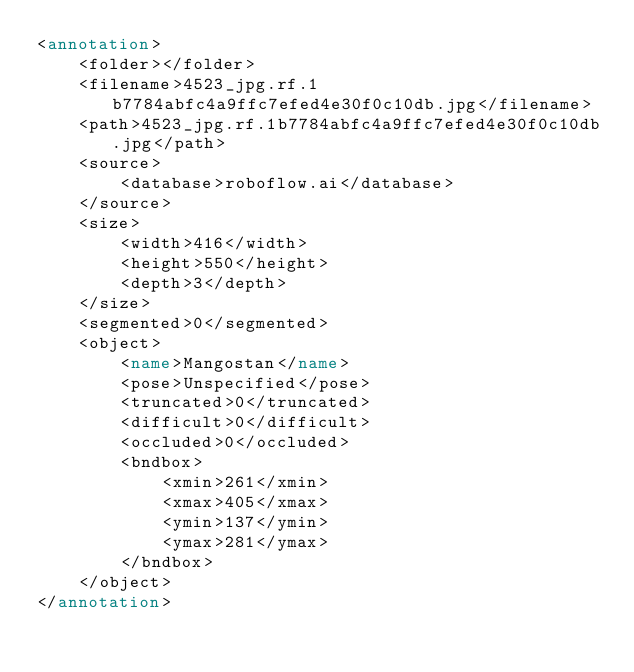Convert code to text. <code><loc_0><loc_0><loc_500><loc_500><_XML_><annotation>
	<folder></folder>
	<filename>4523_jpg.rf.1b7784abfc4a9ffc7efed4e30f0c10db.jpg</filename>
	<path>4523_jpg.rf.1b7784abfc4a9ffc7efed4e30f0c10db.jpg</path>
	<source>
		<database>roboflow.ai</database>
	</source>
	<size>
		<width>416</width>
		<height>550</height>
		<depth>3</depth>
	</size>
	<segmented>0</segmented>
	<object>
		<name>Mangostan</name>
		<pose>Unspecified</pose>
		<truncated>0</truncated>
		<difficult>0</difficult>
		<occluded>0</occluded>
		<bndbox>
			<xmin>261</xmin>
			<xmax>405</xmax>
			<ymin>137</ymin>
			<ymax>281</ymax>
		</bndbox>
	</object>
</annotation>
</code> 